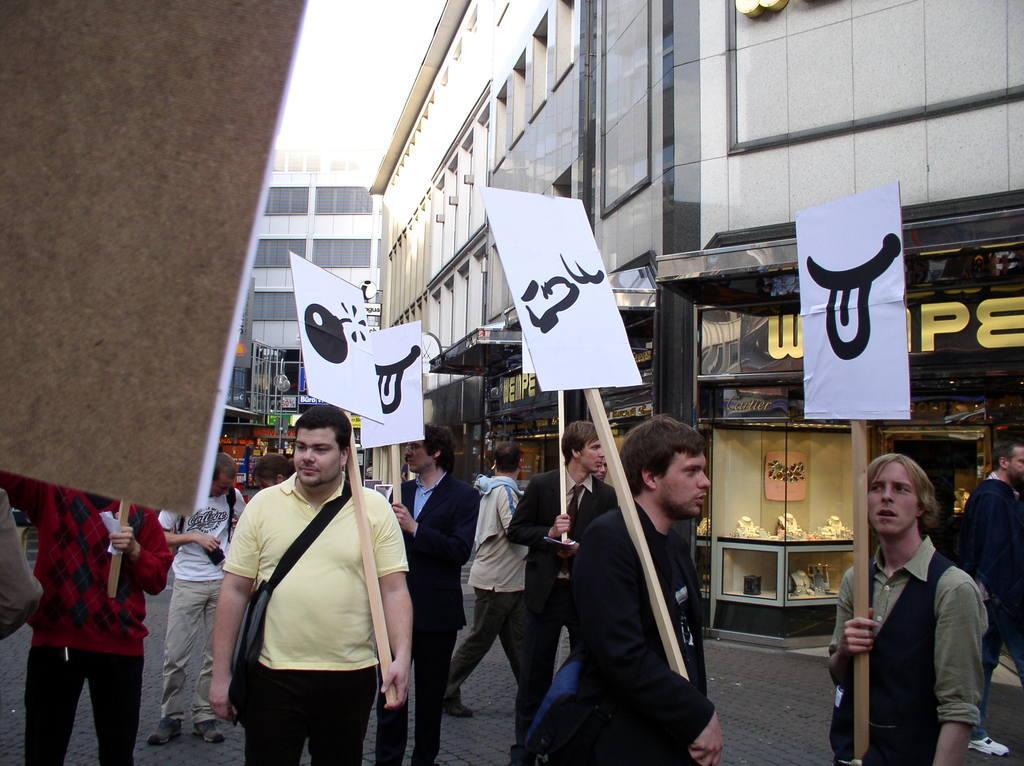Can you describe this image briefly? In this picture we can see buildings and people holding boards in their hands. 